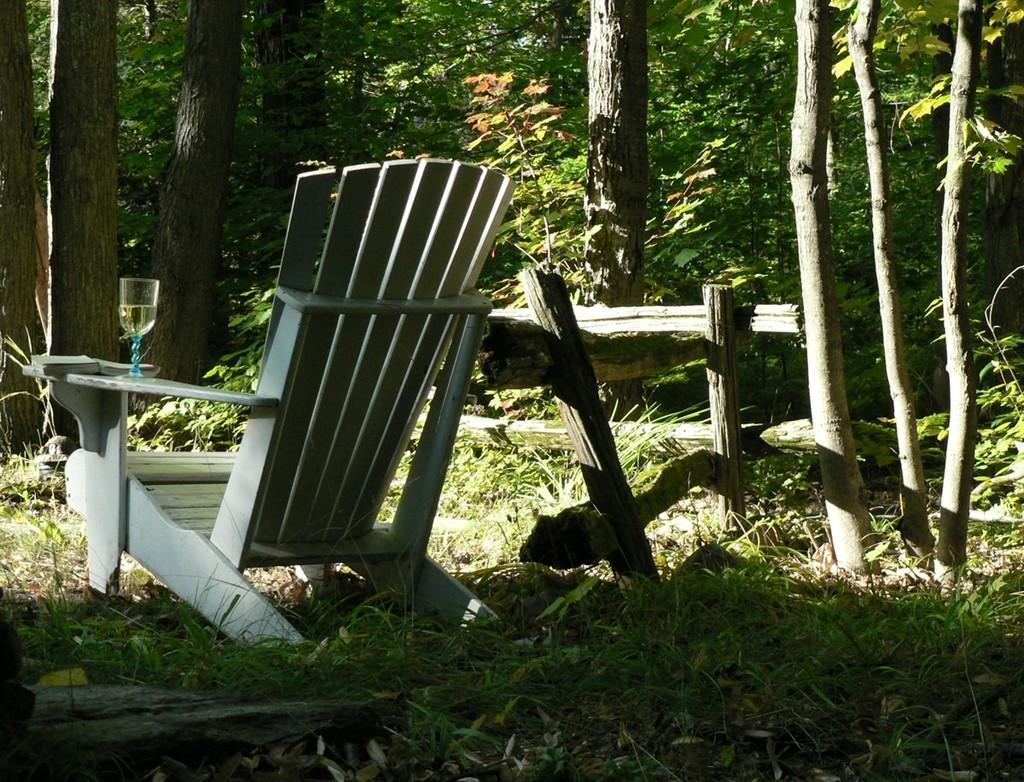How would you summarize this image in a sentence or two? In the image I can see a chair, table on which there is a glass and also I can see some trees and plants. 